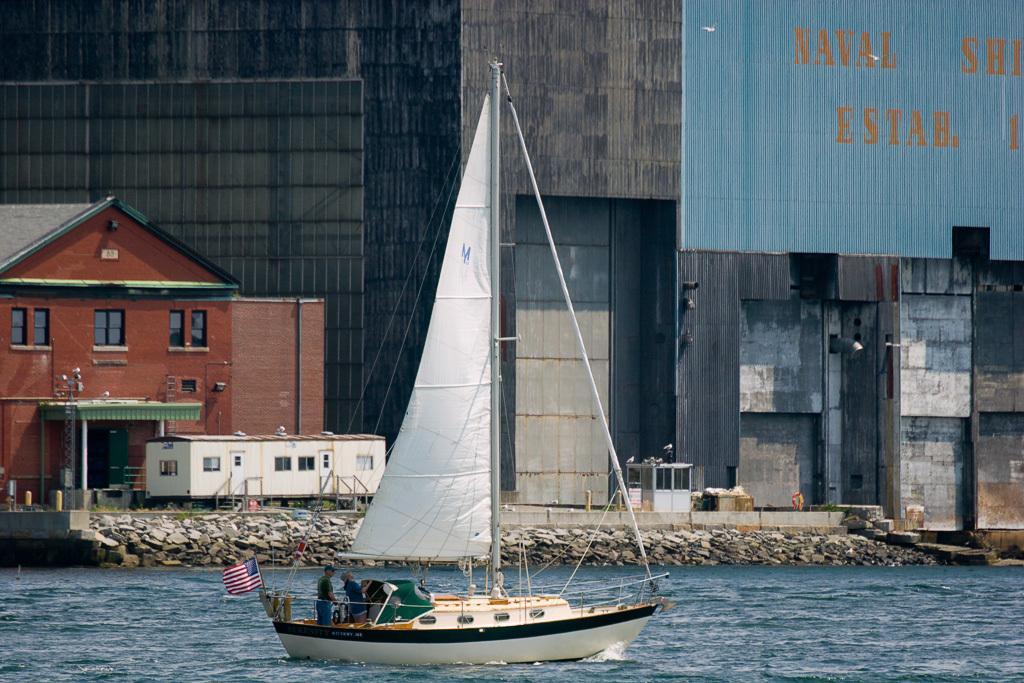How would you summarize this image in a sentence or two? In this picture we can see water at the bottom, there is a boat in the water, we can see two persons and a flag in the boat, there are some stones in the middle, in the background we can see buildings. 